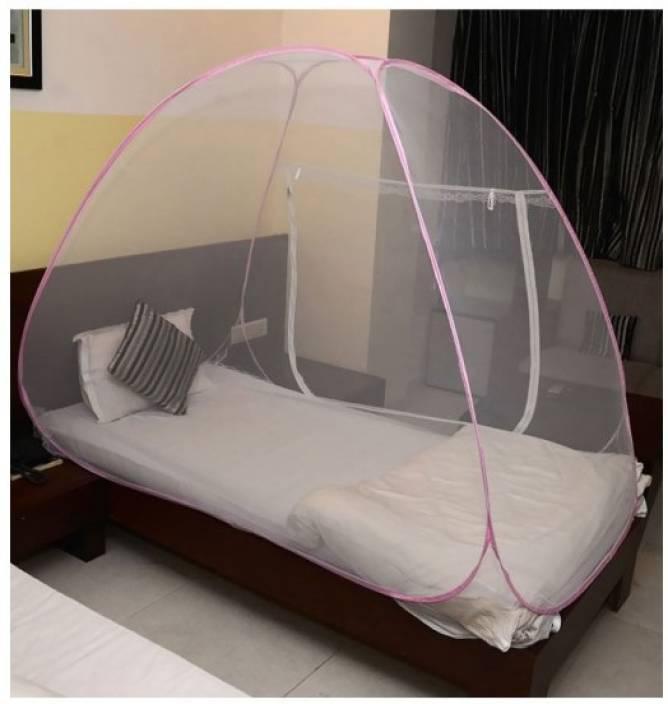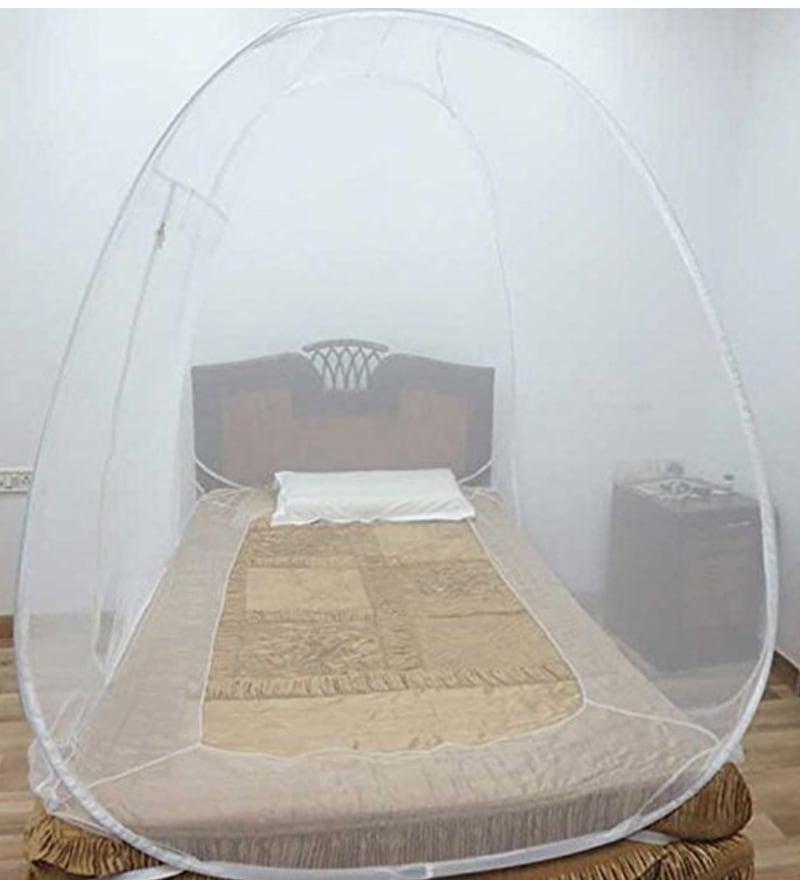The first image is the image on the left, the second image is the image on the right. Given the left and right images, does the statement "One of the mattresses is blue and white." hold true? Answer yes or no. No. 